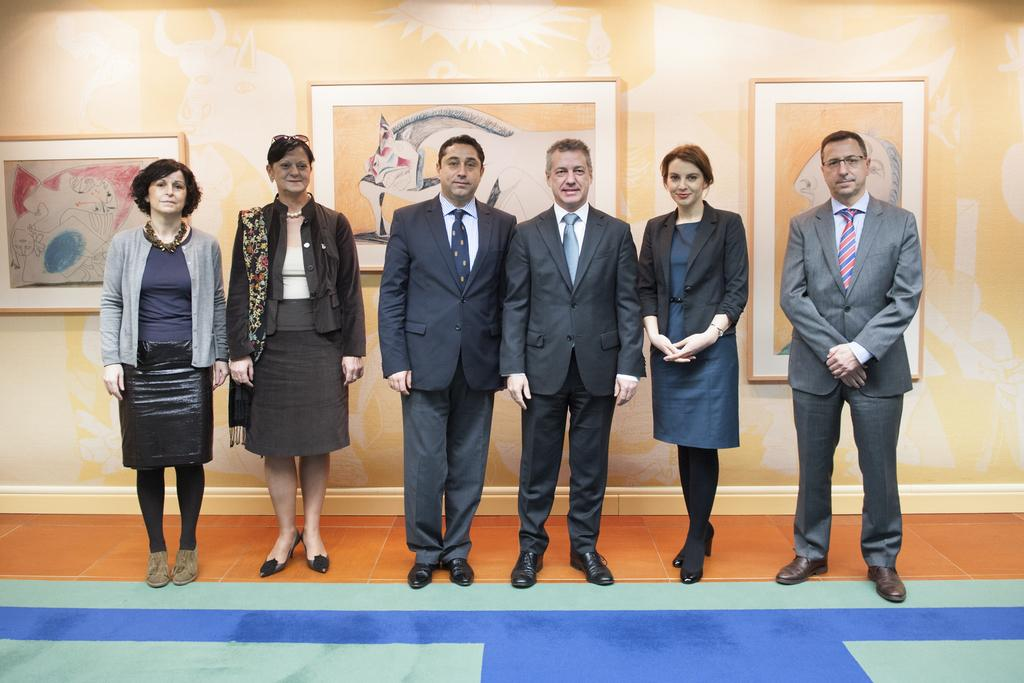What are the people in the image doing? The people in the image are standing on the ground. What can be seen in the background of the image? There is a wall and photo frames in the background of the image. What type of carriage is being used by the people in the image? There is no carriage present in the image; the people are standing on the ground. What relation do the people in the image have to each other? The provided facts do not give any information about the relationship between the people in the image. 